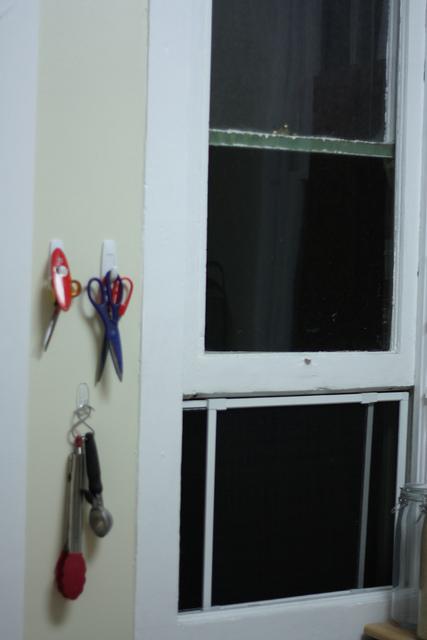Was the picture taken during the day?
Write a very short answer. No. Is each hook holding the same number of items?
Give a very brief answer. Yes. Is there a screen in the window?
Write a very short answer. Yes. How many window is there?
Answer briefly. 2. How many pairs of scissor are in the photo?
Be succinct. 2. 